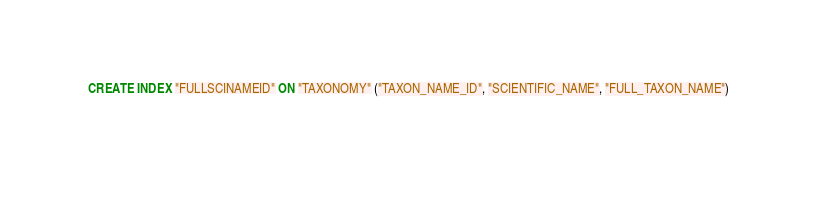Convert code to text. <code><loc_0><loc_0><loc_500><loc_500><_SQL_>
  CREATE INDEX "FULLSCINAMEID" ON "TAXONOMY" ("TAXON_NAME_ID", "SCIENTIFIC_NAME", "FULL_TAXON_NAME") 
  </code> 